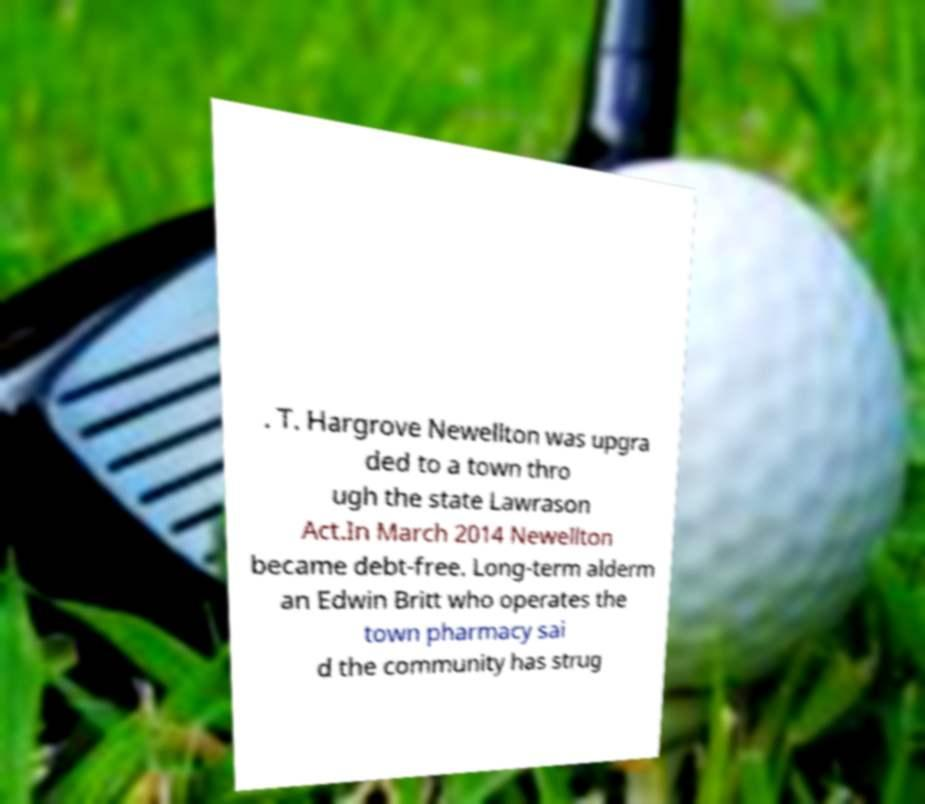There's text embedded in this image that I need extracted. Can you transcribe it verbatim? . T. Hargrove Newellton was upgra ded to a town thro ugh the state Lawrason Act.In March 2014 Newellton became debt-free. Long-term alderm an Edwin Britt who operates the town pharmacy sai d the community has strug 